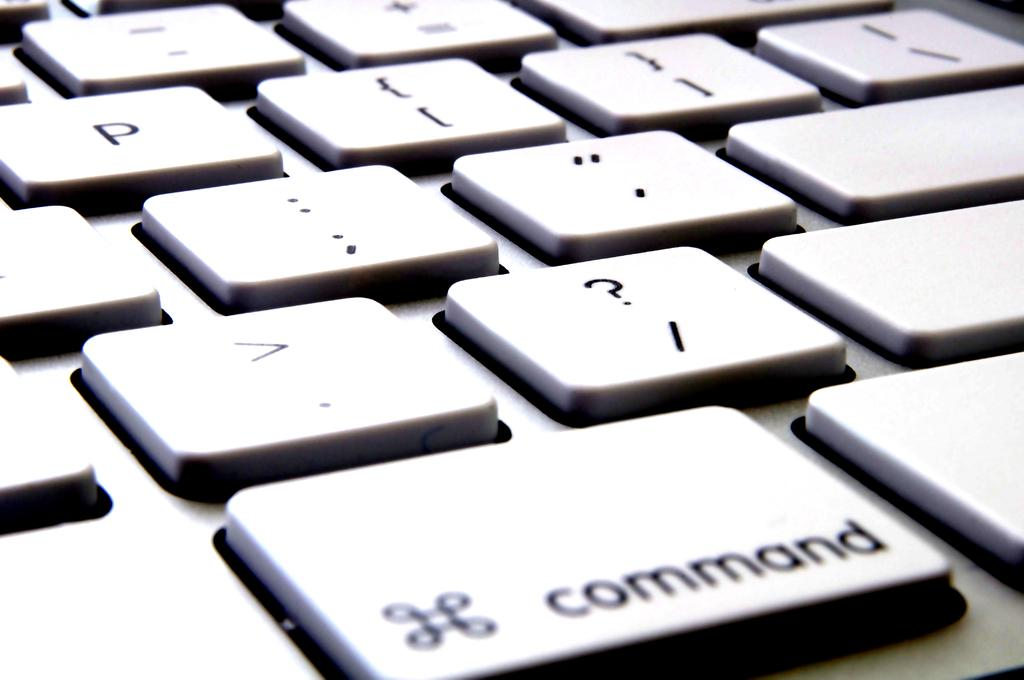<image>
Present a compact description of the photo's key features. The command key is the focus of the keyboard shown. 